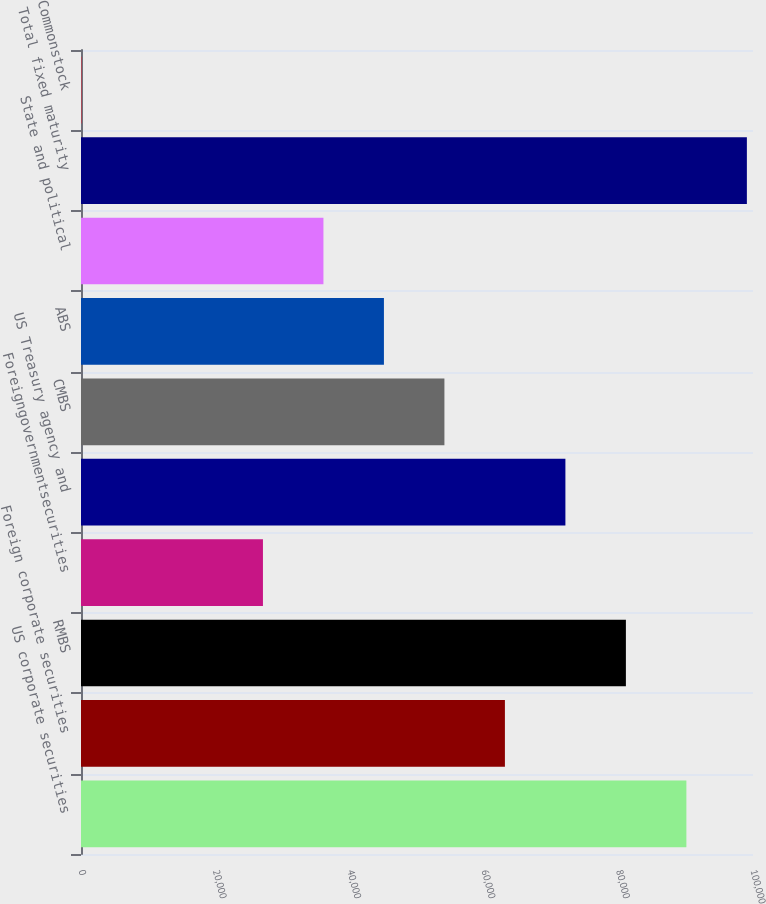Convert chart. <chart><loc_0><loc_0><loc_500><loc_500><bar_chart><fcel>US corporate securities<fcel>Foreign corporate securities<fcel>RMBS<fcel>Foreigngovernmentsecurities<fcel>US Treasury agency and<fcel>CMBS<fcel>ABS<fcel>State and political<fcel>Total fixed maturity<fcel>Commonstock<nl><fcel>90087<fcel>63081.9<fcel>81085.3<fcel>27075.1<fcel>72083.6<fcel>54080.2<fcel>45078.5<fcel>36076.8<fcel>99088.7<fcel>70<nl></chart> 